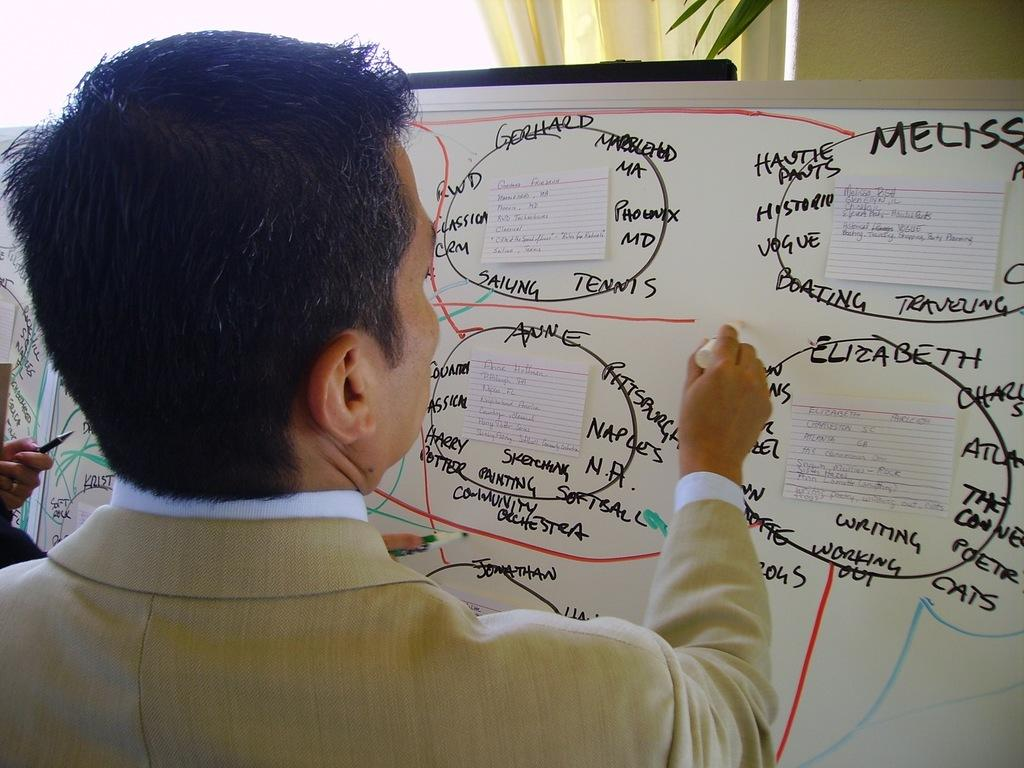<image>
Create a compact narrative representing the image presented. The man is writing on a white board, some of the things it says on there are Elizabeth, Anne, Softball, and Pittsburgh. 